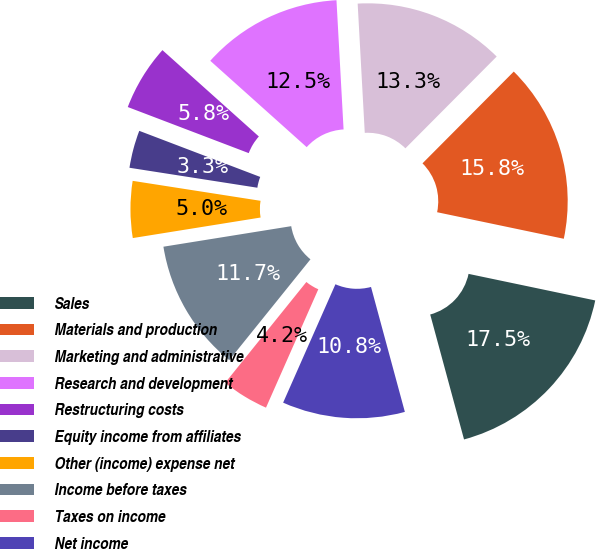Convert chart to OTSL. <chart><loc_0><loc_0><loc_500><loc_500><pie_chart><fcel>Sales<fcel>Materials and production<fcel>Marketing and administrative<fcel>Research and development<fcel>Restructuring costs<fcel>Equity income from affiliates<fcel>Other (income) expense net<fcel>Income before taxes<fcel>Taxes on income<fcel>Net income<nl><fcel>17.5%<fcel>15.83%<fcel>13.33%<fcel>12.5%<fcel>5.83%<fcel>3.33%<fcel>5.0%<fcel>11.67%<fcel>4.17%<fcel>10.83%<nl></chart> 